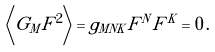Convert formula to latex. <formula><loc_0><loc_0><loc_500><loc_500>\left \langle G _ { M } F ^ { 2 } \right \rangle = g _ { M N K } F ^ { N } F ^ { K } = 0 \, .</formula> 